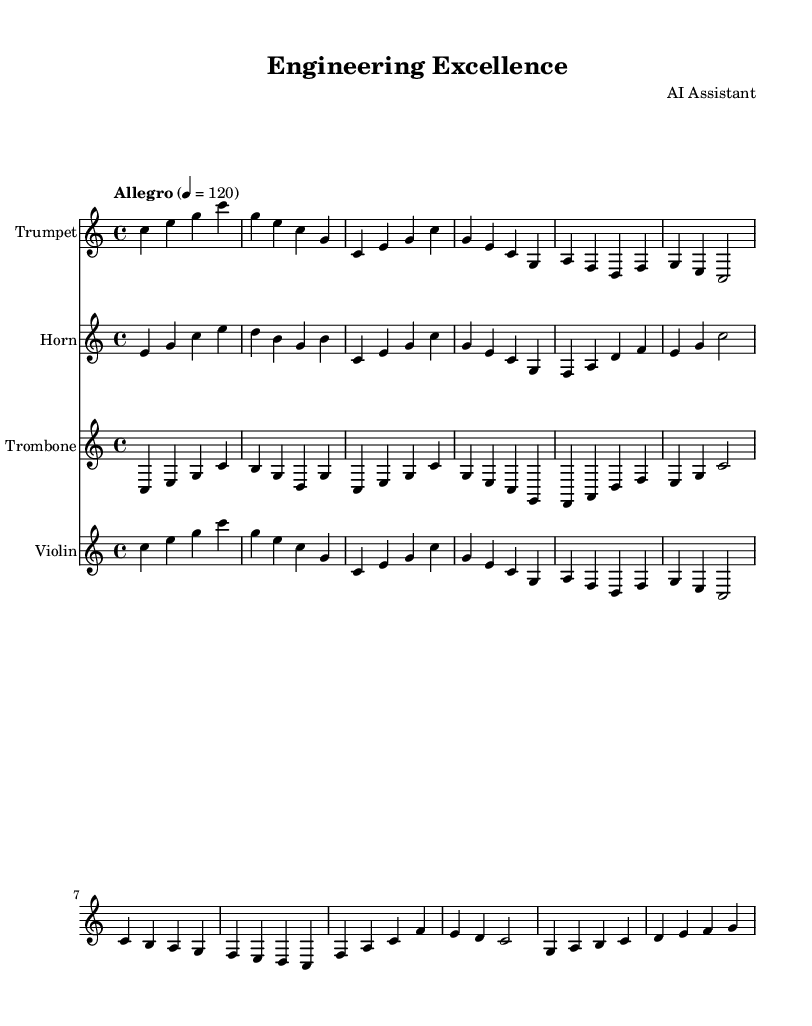What is the key signature of this music? The key signature is C major, which has no sharps or flats.
Answer: C major What is the time signature of this music? The time signature is indicated at the beginning of the score and is shown as 4/4, meaning there are four beats in each measure.
Answer: 4/4 What is the tempo marking of this music? The tempo marking indicates the speed of the music and is stated as "Allegro" with a metronome marking of 120 beats per minute.
Answer: Allegro How many different instruments are featured in this score? The score includes four different instruments as indicated by the separate staves: Trumpet, Horn, Trombone, and Violin.
Answer: Four What is the first note in the Trumpet music? The first note in the Trumpet music is a C, which is the starting note of the introduction section.
Answer: C Which theme follows the introduction in the Trumpet music? The first theme that follows the introduction in the Trumpet music is Main Theme A, which consists of notes including C, E, and G.
Answer: Main Theme A What is the last measure of the Bridge section in the music for Horn? The last measure of the Bridge section in the Horn music ends with a G note.
Answer: G 